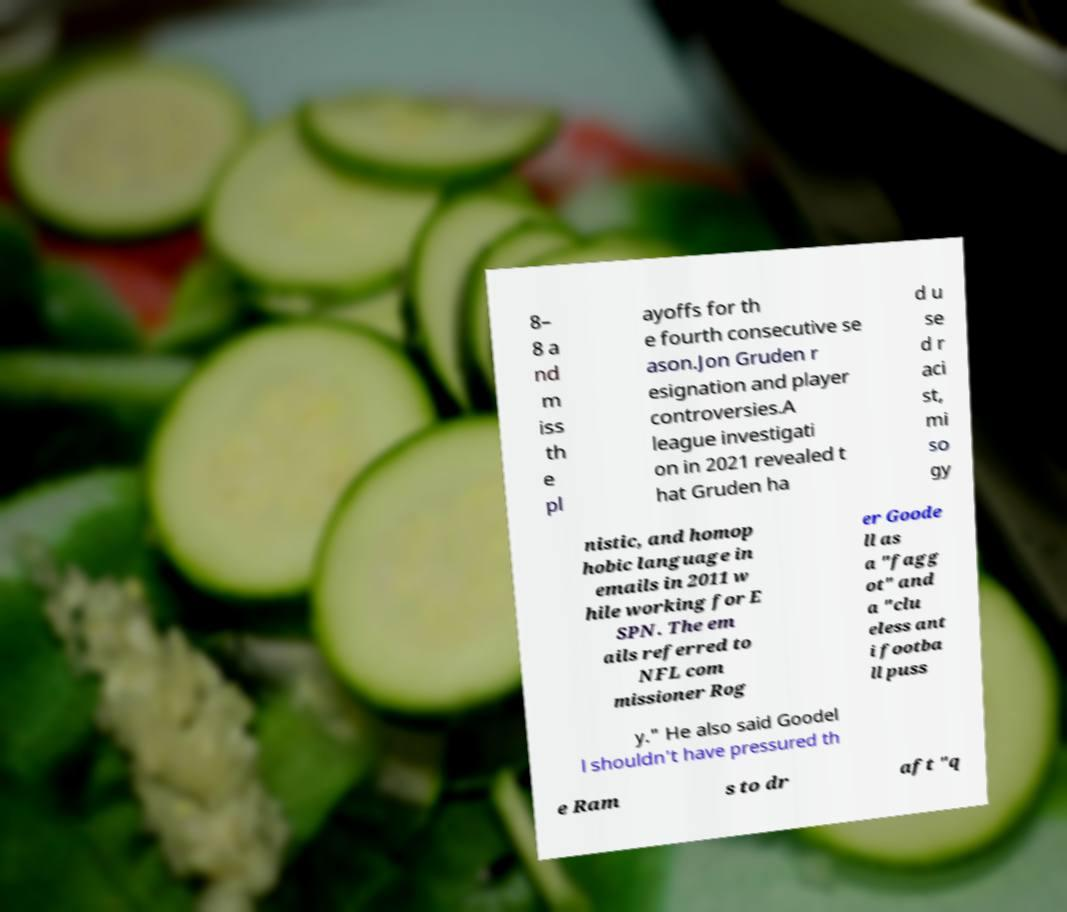I need the written content from this picture converted into text. Can you do that? 8– 8 a nd m iss th e pl ayoffs for th e fourth consecutive se ason.Jon Gruden r esignation and player controversies.A league investigati on in 2021 revealed t hat Gruden ha d u se d r aci st, mi so gy nistic, and homop hobic language in emails in 2011 w hile working for E SPN. The em ails referred to NFL com missioner Rog er Goode ll as a "fagg ot" and a "clu eless ant i footba ll puss y." He also said Goodel l shouldn't have pressured th e Ram s to dr aft "q 